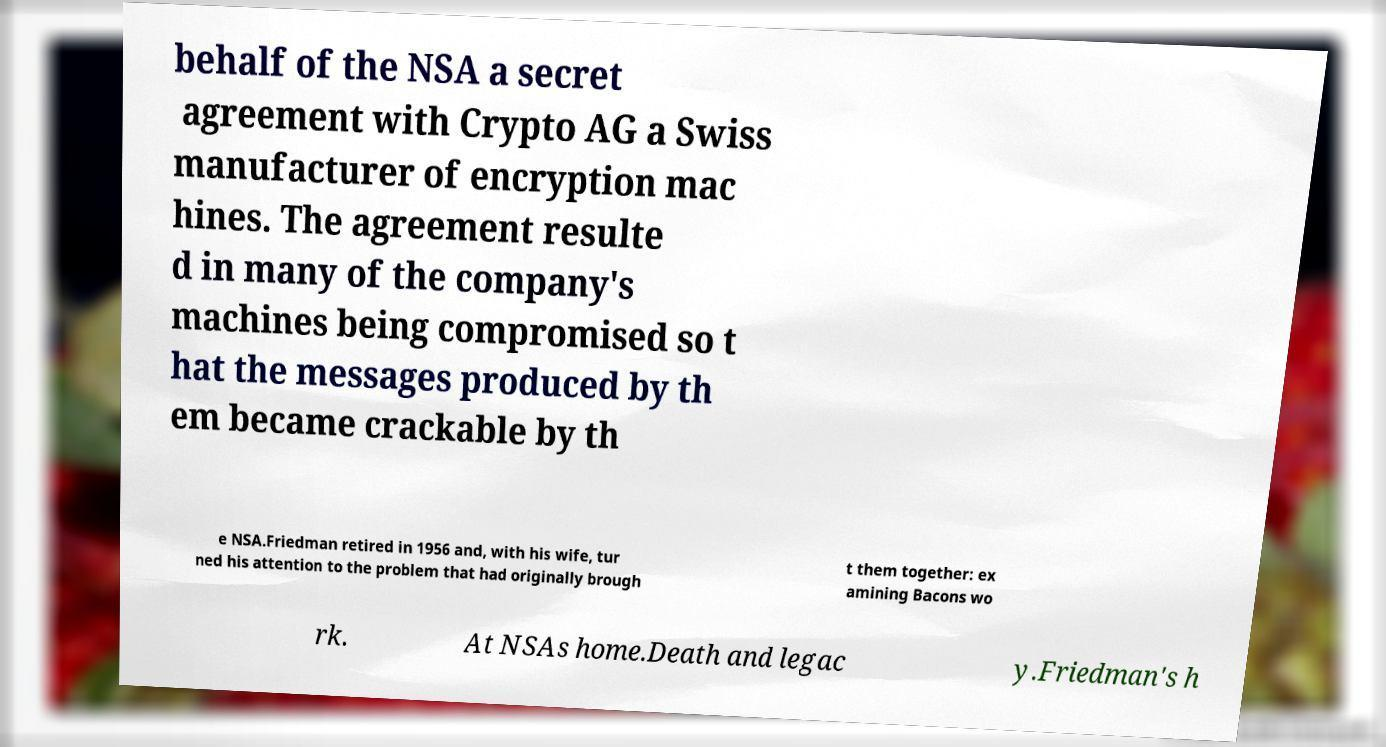Please read and relay the text visible in this image. What does it say? behalf of the NSA a secret agreement with Crypto AG a Swiss manufacturer of encryption mac hines. The agreement resulte d in many of the company's machines being compromised so t hat the messages produced by th em became crackable by th e NSA.Friedman retired in 1956 and, with his wife, tur ned his attention to the problem that had originally brough t them together: ex amining Bacons wo rk. At NSAs home.Death and legac y.Friedman's h 